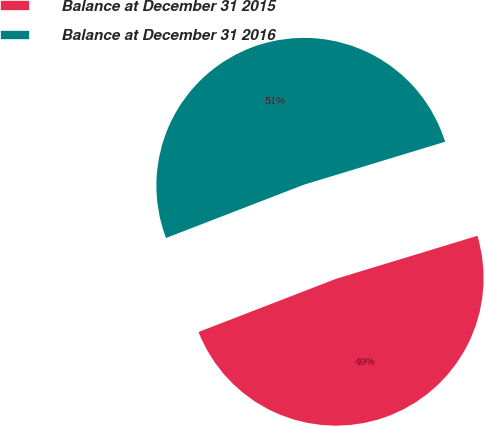Convert chart. <chart><loc_0><loc_0><loc_500><loc_500><pie_chart><fcel>Balance at December 31 2015<fcel>Balance at December 31 2016<nl><fcel>48.83%<fcel>51.17%<nl></chart> 